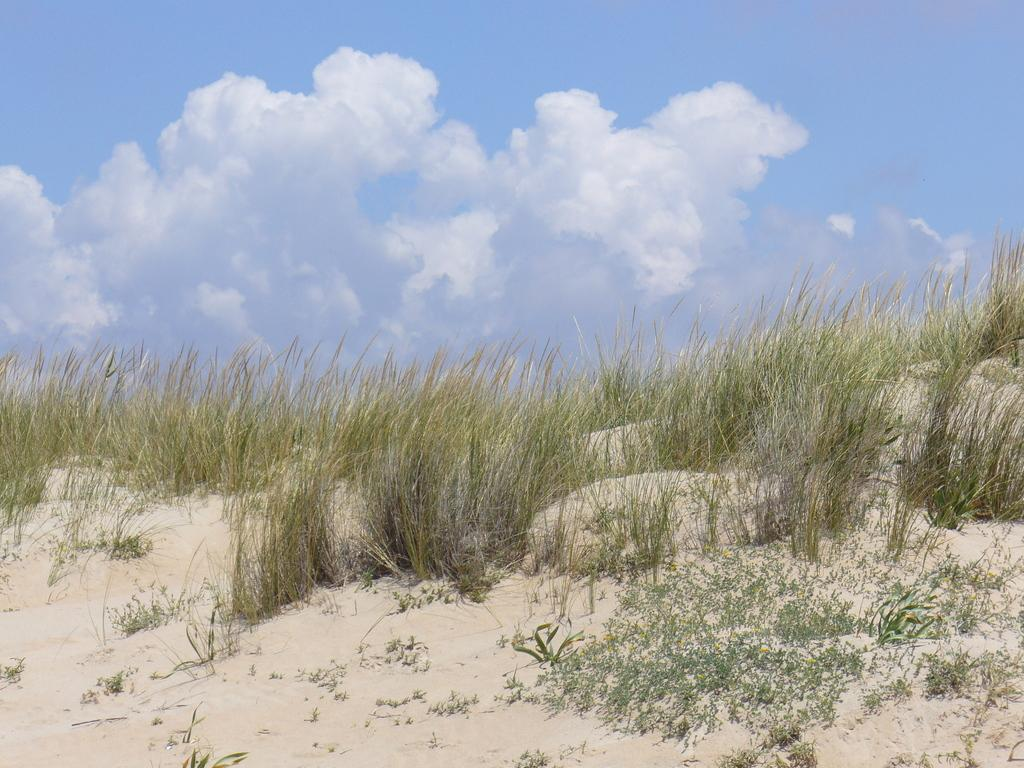What is visible in the background of the image? The sky is visible in the image. What can be seen in the sky in the image? Clouds are present in the image. What type of vegetation is visible in the image? Grass is visible in the image. What is the price of the wine being served in the image? There is no wine or any indication of a price in the image. 